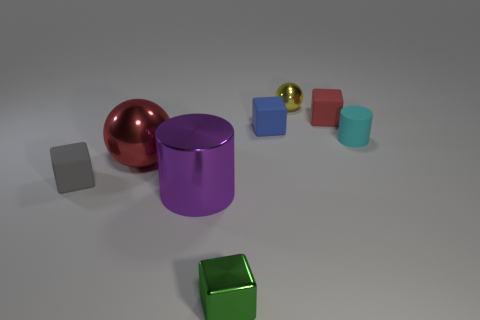Subtract all blue rubber cubes. How many cubes are left? 3 Add 2 big purple matte spheres. How many objects exist? 10 Subtract all gray cubes. How many cubes are left? 3 Subtract all cylinders. How many objects are left? 6 Subtract 1 spheres. How many spheres are left? 1 Subtract all purple cylinders. Subtract all green cubes. How many cylinders are left? 1 Subtract all cyan cylinders. How many blue spheres are left? 0 Subtract all large gray shiny cylinders. Subtract all rubber cylinders. How many objects are left? 7 Add 4 large red shiny balls. How many large red shiny balls are left? 5 Add 6 small green metallic blocks. How many small green metallic blocks exist? 7 